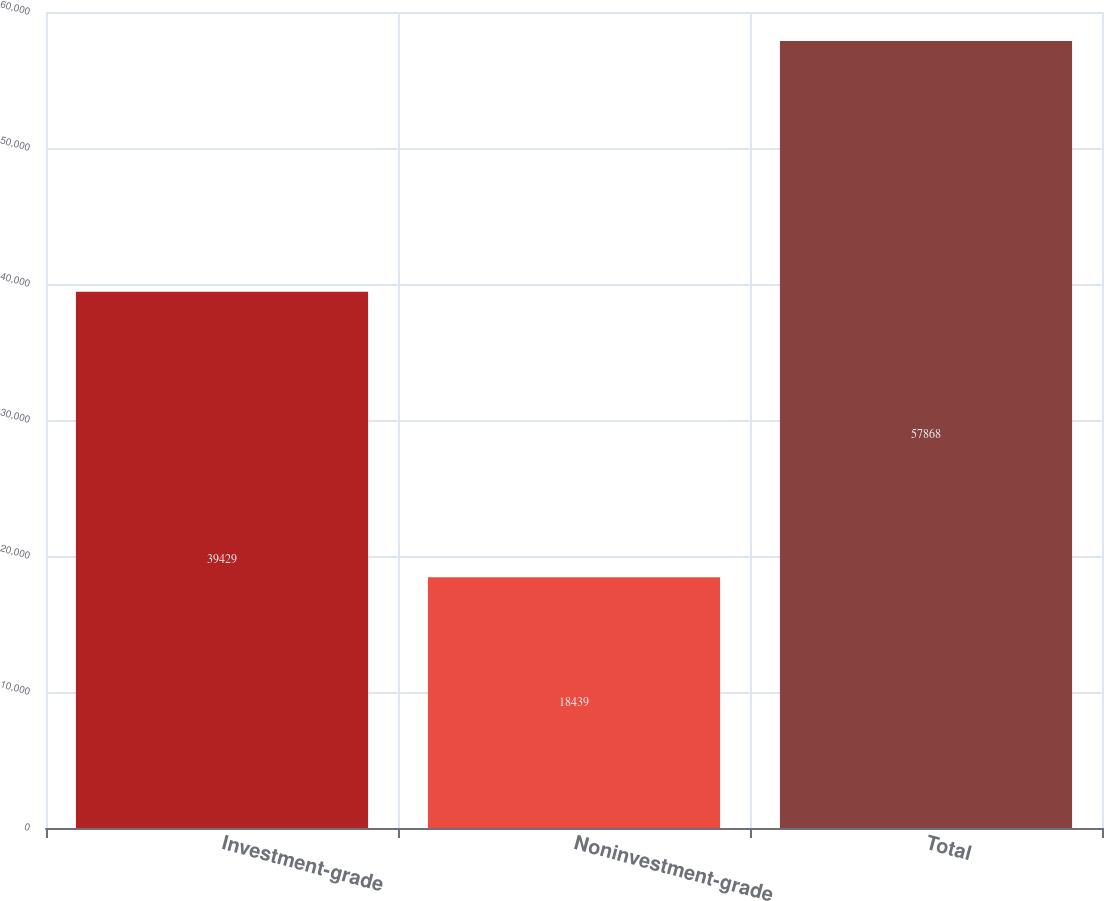<chart> <loc_0><loc_0><loc_500><loc_500><bar_chart><fcel>Investment-grade<fcel>Noninvestment-grade<fcel>Total<nl><fcel>39429<fcel>18439<fcel>57868<nl></chart> 